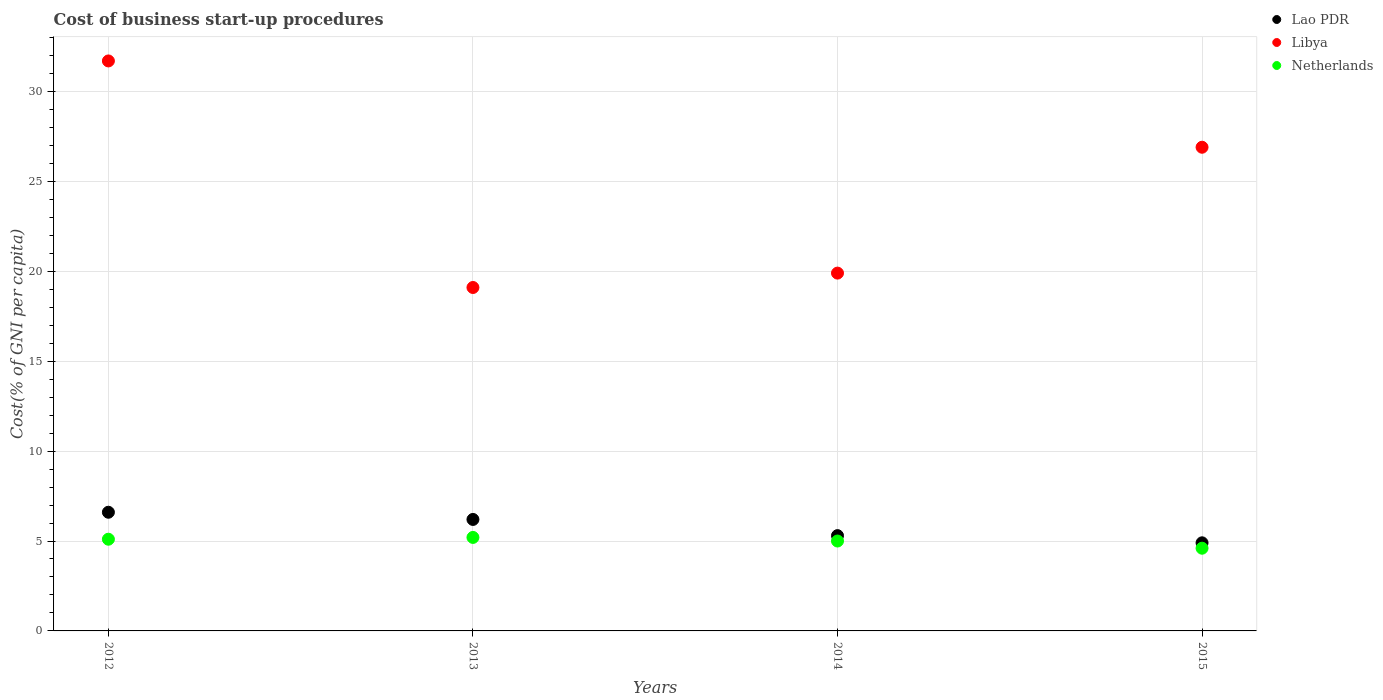Is the number of dotlines equal to the number of legend labels?
Provide a succinct answer. Yes. What is the cost of business start-up procedures in Libya in 2015?
Make the answer very short. 26.9. Across all years, what is the maximum cost of business start-up procedures in Libya?
Make the answer very short. 31.7. Across all years, what is the minimum cost of business start-up procedures in Netherlands?
Offer a terse response. 4.6. What is the difference between the cost of business start-up procedures in Netherlands in 2014 and that in 2015?
Give a very brief answer. 0.4. What is the difference between the cost of business start-up procedures in Netherlands in 2013 and the cost of business start-up procedures in Libya in 2012?
Offer a very short reply. -26.5. What is the average cost of business start-up procedures in Lao PDR per year?
Offer a very short reply. 5.75. In the year 2012, what is the difference between the cost of business start-up procedures in Libya and cost of business start-up procedures in Lao PDR?
Your answer should be compact. 25.1. What is the ratio of the cost of business start-up procedures in Lao PDR in 2012 to that in 2015?
Provide a short and direct response. 1.35. Is the cost of business start-up procedures in Netherlands in 2014 less than that in 2015?
Keep it short and to the point. No. Is the difference between the cost of business start-up procedures in Libya in 2014 and 2015 greater than the difference between the cost of business start-up procedures in Lao PDR in 2014 and 2015?
Your answer should be compact. No. What is the difference between the highest and the second highest cost of business start-up procedures in Lao PDR?
Keep it short and to the point. 0.4. What is the difference between the highest and the lowest cost of business start-up procedures in Netherlands?
Keep it short and to the point. 0.6. Is it the case that in every year, the sum of the cost of business start-up procedures in Lao PDR and cost of business start-up procedures in Libya  is greater than the cost of business start-up procedures in Netherlands?
Provide a succinct answer. Yes. Is the cost of business start-up procedures in Lao PDR strictly greater than the cost of business start-up procedures in Libya over the years?
Your response must be concise. No. How many dotlines are there?
Provide a succinct answer. 3. Are the values on the major ticks of Y-axis written in scientific E-notation?
Your answer should be compact. No. Where does the legend appear in the graph?
Your answer should be compact. Top right. How many legend labels are there?
Provide a short and direct response. 3. How are the legend labels stacked?
Ensure brevity in your answer.  Vertical. What is the title of the graph?
Your answer should be compact. Cost of business start-up procedures. What is the label or title of the Y-axis?
Offer a terse response. Cost(% of GNI per capita). What is the Cost(% of GNI per capita) of Lao PDR in 2012?
Offer a terse response. 6.6. What is the Cost(% of GNI per capita) in Libya in 2012?
Ensure brevity in your answer.  31.7. What is the Cost(% of GNI per capita) in Netherlands in 2012?
Make the answer very short. 5.1. What is the Cost(% of GNI per capita) of Lao PDR in 2013?
Provide a short and direct response. 6.2. What is the Cost(% of GNI per capita) in Libya in 2013?
Your response must be concise. 19.1. What is the Cost(% of GNI per capita) in Netherlands in 2013?
Provide a short and direct response. 5.2. What is the Cost(% of GNI per capita) in Lao PDR in 2015?
Keep it short and to the point. 4.9. What is the Cost(% of GNI per capita) in Libya in 2015?
Your answer should be very brief. 26.9. Across all years, what is the maximum Cost(% of GNI per capita) in Lao PDR?
Make the answer very short. 6.6. Across all years, what is the maximum Cost(% of GNI per capita) of Libya?
Your response must be concise. 31.7. Across all years, what is the minimum Cost(% of GNI per capita) of Lao PDR?
Provide a succinct answer. 4.9. Across all years, what is the minimum Cost(% of GNI per capita) of Libya?
Provide a succinct answer. 19.1. What is the total Cost(% of GNI per capita) in Lao PDR in the graph?
Offer a terse response. 23. What is the total Cost(% of GNI per capita) of Libya in the graph?
Your response must be concise. 97.6. What is the total Cost(% of GNI per capita) in Netherlands in the graph?
Your answer should be compact. 19.9. What is the difference between the Cost(% of GNI per capita) in Netherlands in 2012 and that in 2013?
Your answer should be very brief. -0.1. What is the difference between the Cost(% of GNI per capita) in Netherlands in 2012 and that in 2015?
Your response must be concise. 0.5. What is the difference between the Cost(% of GNI per capita) of Lao PDR in 2013 and that in 2015?
Offer a very short reply. 1.3. What is the difference between the Cost(% of GNI per capita) in Libya in 2013 and that in 2015?
Your response must be concise. -7.8. What is the difference between the Cost(% of GNI per capita) in Lao PDR in 2014 and that in 2015?
Provide a short and direct response. 0.4. What is the difference between the Cost(% of GNI per capita) of Netherlands in 2014 and that in 2015?
Your answer should be very brief. 0.4. What is the difference between the Cost(% of GNI per capita) in Lao PDR in 2012 and the Cost(% of GNI per capita) in Libya in 2013?
Provide a succinct answer. -12.5. What is the difference between the Cost(% of GNI per capita) of Lao PDR in 2012 and the Cost(% of GNI per capita) of Netherlands in 2013?
Keep it short and to the point. 1.4. What is the difference between the Cost(% of GNI per capita) of Lao PDR in 2012 and the Cost(% of GNI per capita) of Netherlands in 2014?
Your answer should be compact. 1.6. What is the difference between the Cost(% of GNI per capita) in Libya in 2012 and the Cost(% of GNI per capita) in Netherlands in 2014?
Your answer should be compact. 26.7. What is the difference between the Cost(% of GNI per capita) of Lao PDR in 2012 and the Cost(% of GNI per capita) of Libya in 2015?
Your response must be concise. -20.3. What is the difference between the Cost(% of GNI per capita) in Libya in 2012 and the Cost(% of GNI per capita) in Netherlands in 2015?
Your answer should be very brief. 27.1. What is the difference between the Cost(% of GNI per capita) of Lao PDR in 2013 and the Cost(% of GNI per capita) of Libya in 2014?
Offer a terse response. -13.7. What is the difference between the Cost(% of GNI per capita) in Lao PDR in 2013 and the Cost(% of GNI per capita) in Libya in 2015?
Provide a short and direct response. -20.7. What is the difference between the Cost(% of GNI per capita) in Lao PDR in 2014 and the Cost(% of GNI per capita) in Libya in 2015?
Provide a short and direct response. -21.6. What is the difference between the Cost(% of GNI per capita) in Lao PDR in 2014 and the Cost(% of GNI per capita) in Netherlands in 2015?
Your answer should be compact. 0.7. What is the average Cost(% of GNI per capita) of Lao PDR per year?
Keep it short and to the point. 5.75. What is the average Cost(% of GNI per capita) in Libya per year?
Provide a short and direct response. 24.4. What is the average Cost(% of GNI per capita) of Netherlands per year?
Offer a terse response. 4.97. In the year 2012, what is the difference between the Cost(% of GNI per capita) of Lao PDR and Cost(% of GNI per capita) of Libya?
Keep it short and to the point. -25.1. In the year 2012, what is the difference between the Cost(% of GNI per capita) of Lao PDR and Cost(% of GNI per capita) of Netherlands?
Provide a succinct answer. 1.5. In the year 2012, what is the difference between the Cost(% of GNI per capita) in Libya and Cost(% of GNI per capita) in Netherlands?
Offer a very short reply. 26.6. In the year 2013, what is the difference between the Cost(% of GNI per capita) of Libya and Cost(% of GNI per capita) of Netherlands?
Your response must be concise. 13.9. In the year 2014, what is the difference between the Cost(% of GNI per capita) in Lao PDR and Cost(% of GNI per capita) in Libya?
Your answer should be very brief. -14.6. In the year 2015, what is the difference between the Cost(% of GNI per capita) of Lao PDR and Cost(% of GNI per capita) of Libya?
Keep it short and to the point. -22. In the year 2015, what is the difference between the Cost(% of GNI per capita) in Lao PDR and Cost(% of GNI per capita) in Netherlands?
Your answer should be compact. 0.3. In the year 2015, what is the difference between the Cost(% of GNI per capita) of Libya and Cost(% of GNI per capita) of Netherlands?
Your answer should be very brief. 22.3. What is the ratio of the Cost(% of GNI per capita) in Lao PDR in 2012 to that in 2013?
Make the answer very short. 1.06. What is the ratio of the Cost(% of GNI per capita) in Libya in 2012 to that in 2013?
Ensure brevity in your answer.  1.66. What is the ratio of the Cost(% of GNI per capita) in Netherlands in 2012 to that in 2013?
Offer a terse response. 0.98. What is the ratio of the Cost(% of GNI per capita) of Lao PDR in 2012 to that in 2014?
Offer a terse response. 1.25. What is the ratio of the Cost(% of GNI per capita) in Libya in 2012 to that in 2014?
Provide a succinct answer. 1.59. What is the ratio of the Cost(% of GNI per capita) of Lao PDR in 2012 to that in 2015?
Offer a very short reply. 1.35. What is the ratio of the Cost(% of GNI per capita) in Libya in 2012 to that in 2015?
Offer a terse response. 1.18. What is the ratio of the Cost(% of GNI per capita) in Netherlands in 2012 to that in 2015?
Give a very brief answer. 1.11. What is the ratio of the Cost(% of GNI per capita) of Lao PDR in 2013 to that in 2014?
Ensure brevity in your answer.  1.17. What is the ratio of the Cost(% of GNI per capita) of Libya in 2013 to that in 2014?
Keep it short and to the point. 0.96. What is the ratio of the Cost(% of GNI per capita) of Lao PDR in 2013 to that in 2015?
Offer a terse response. 1.27. What is the ratio of the Cost(% of GNI per capita) in Libya in 2013 to that in 2015?
Your response must be concise. 0.71. What is the ratio of the Cost(% of GNI per capita) of Netherlands in 2013 to that in 2015?
Offer a very short reply. 1.13. What is the ratio of the Cost(% of GNI per capita) of Lao PDR in 2014 to that in 2015?
Offer a terse response. 1.08. What is the ratio of the Cost(% of GNI per capita) in Libya in 2014 to that in 2015?
Keep it short and to the point. 0.74. What is the ratio of the Cost(% of GNI per capita) of Netherlands in 2014 to that in 2015?
Your answer should be compact. 1.09. 